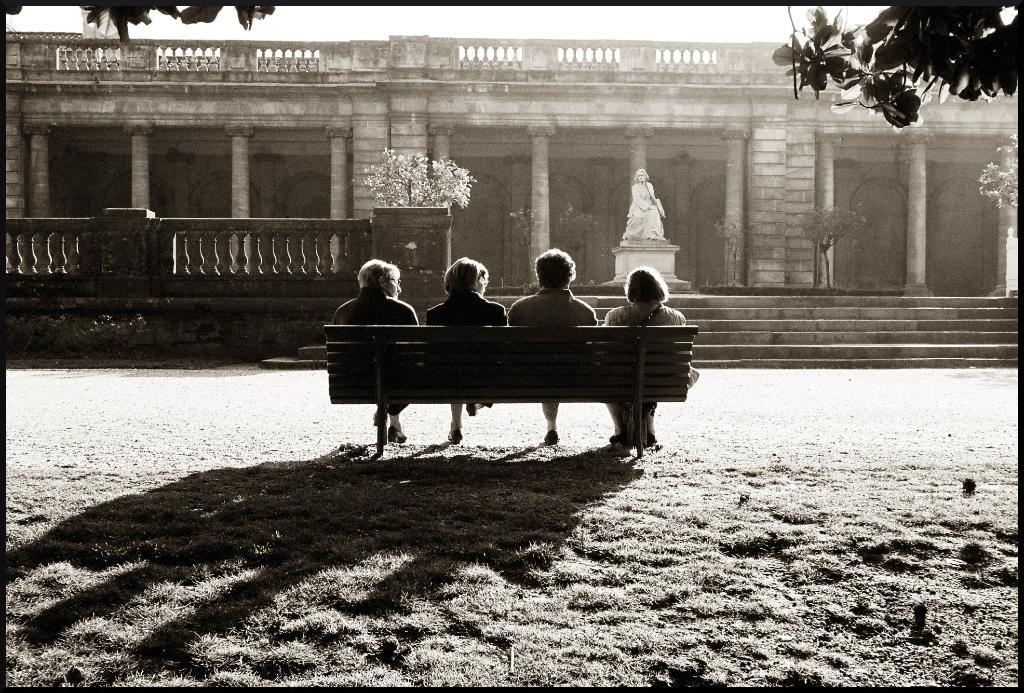How many people are present in the image? There are four people in the image. What are the people doing in the image? The people are sitting on a stand. What can be seen in the background of the image? There is a building in the background of the image. What type of cracker is being passed around by the people in the image? There is no cracker present in the image, and the people are not passing anything around. 